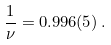<formula> <loc_0><loc_0><loc_500><loc_500>\frac { 1 } { \nu } = 0 . 9 9 6 ( 5 ) \, .</formula> 